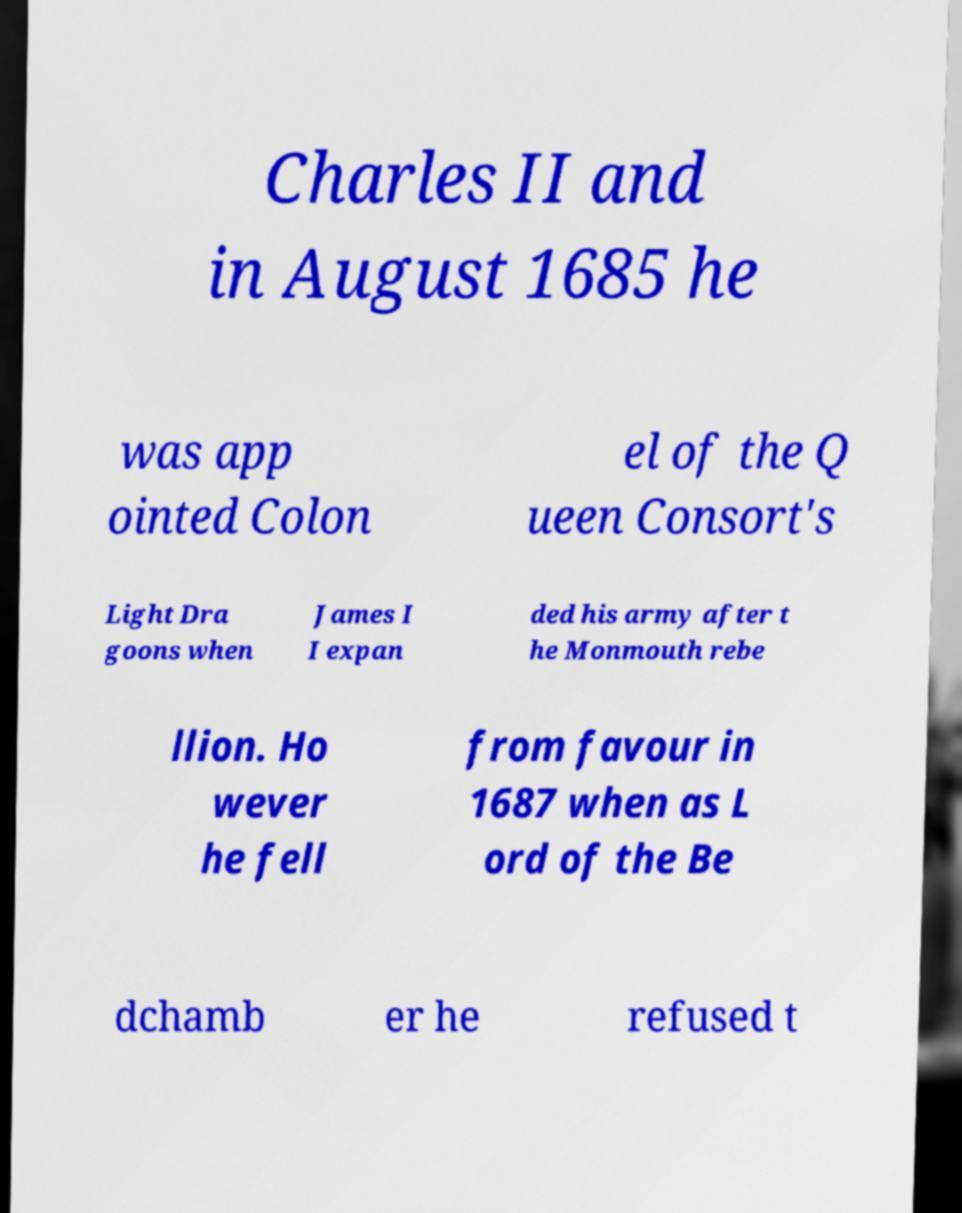I need the written content from this picture converted into text. Can you do that? Charles II and in August 1685 he was app ointed Colon el of the Q ueen Consort's Light Dra goons when James I I expan ded his army after t he Monmouth rebe llion. Ho wever he fell from favour in 1687 when as L ord of the Be dchamb er he refused t 